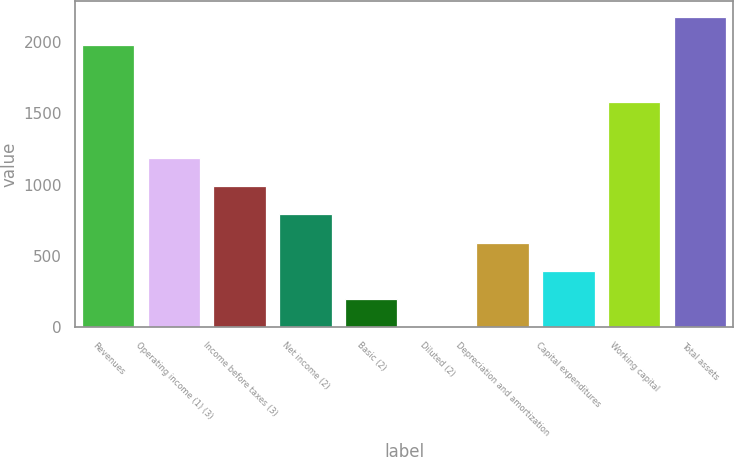<chart> <loc_0><loc_0><loc_500><loc_500><bar_chart><fcel>Revenues<fcel>Operating income (1) (3)<fcel>Income before taxes (3)<fcel>Net income (2)<fcel>Basic (2)<fcel>Diluted (2)<fcel>Depreciation and amortization<fcel>Capital expenditures<fcel>Working capital<fcel>Total assets<nl><fcel>1977.19<fcel>1186.67<fcel>989.04<fcel>791.41<fcel>198.52<fcel>0.89<fcel>593.78<fcel>396.15<fcel>1581.93<fcel>2174.82<nl></chart> 